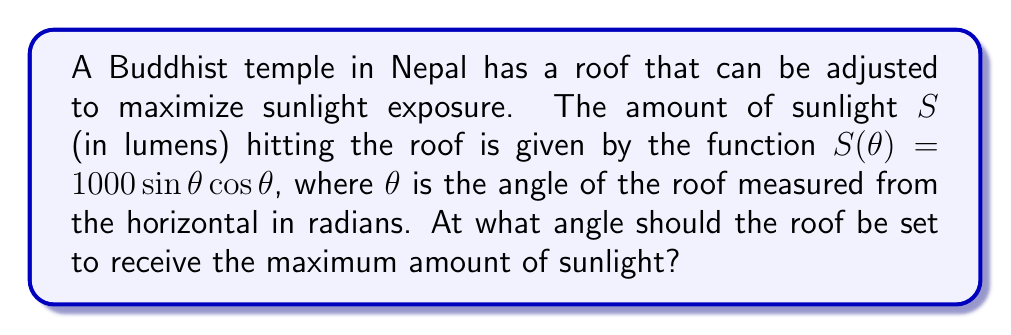Can you answer this question? To find the optimal angle for maximum sunlight exposure, we need to find the maximum of the function $S(\theta) = 1000 \sin\theta \cos\theta$. We can do this by following these steps:

1) First, let's simplify the function using the trigonometric identity $\sin 2\theta = 2\sin\theta \cos\theta$:

   $S(\theta) = 1000 \sin\theta \cos\theta = 500 \sin 2\theta$

2) To find the maximum, we need to find where the derivative of $S(\theta)$ equals zero:

   $\frac{dS}{d\theta} = 500 \cdot 2 \cos 2\theta = 1000 \cos 2\theta$

3) Set the derivative to zero and solve:

   $1000 \cos 2\theta = 0$
   $\cos 2\theta = 0$

4) The cosine function equals zero when its argument is $\frac{\pi}{2}$ or $\frac{3\pi}{2}$:

   $2\theta = \frac{\pi}{2}$ or $2\theta = \frac{3\pi}{2}$
   $\theta = \frac{\pi}{4}$ or $\theta = \frac{3\pi}{4}$

5) To determine which of these is the maximum (rather than the minimum), we can check the second derivative:

   $\frac{d^2S}{d\theta^2} = 1000 \cdot (-2 \sin 2\theta) = -2000 \sin 2\theta$

6) At $\theta = \frac{\pi}{4}$, $\sin 2\theta = 1$, so the second derivative is negative, indicating a maximum.
   At $\theta = \frac{3\pi}{4}$, $\sin 2\theta = -1$, so the second derivative is positive, indicating a minimum.

Therefore, the maximum occurs at $\theta = \frac{\pi}{4}$ radians.

7) Convert to degrees: $\frac{\pi}{4}$ radians = 45°
Answer: 45° 